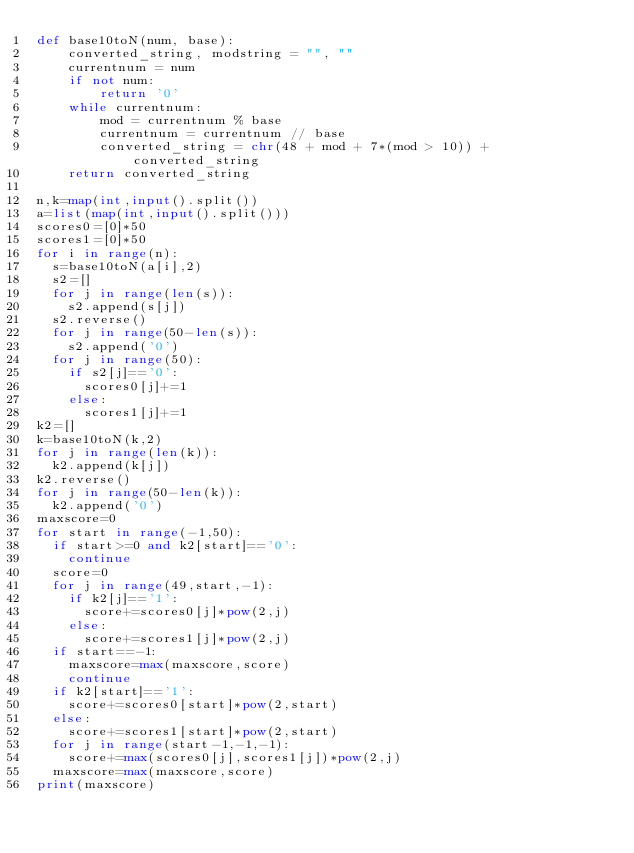<code> <loc_0><loc_0><loc_500><loc_500><_Python_>def base10toN(num, base):
    converted_string, modstring = "", ""
    currentnum = num
    if not num:
        return '0'
    while currentnum:
        mod = currentnum % base
        currentnum = currentnum // base
        converted_string = chr(48 + mod + 7*(mod > 10)) + converted_string
    return converted_string

n,k=map(int,input().split())
a=list(map(int,input().split()))
scores0=[0]*50
scores1=[0]*50
for i in range(n):
  s=base10toN(a[i],2)
  s2=[]
  for j in range(len(s)):
    s2.append(s[j])
  s2.reverse()
  for j in range(50-len(s)):
    s2.append('0')
  for j in range(50):
    if s2[j]=='0':
      scores0[j]+=1
    else:
      scores1[j]+=1
k2=[]
k=base10toN(k,2)
for j in range(len(k)):
  k2.append(k[j])
k2.reverse()
for j in range(50-len(k)):
  k2.append('0')
maxscore=0
for start in range(-1,50):
  if start>=0 and k2[start]=='0':
    continue
  score=0
  for j in range(49,start,-1):
    if k2[j]=='1':
      score+=scores0[j]*pow(2,j)
    else:
      score+=scores1[j]*pow(2,j)
  if start==-1:
    maxscore=max(maxscore,score)
    continue
  if k2[start]=='1':
    score+=scores0[start]*pow(2,start)
  else:
    score+=scores1[start]*pow(2,start)
  for j in range(start-1,-1,-1):
    score+=max(scores0[j],scores1[j])*pow(2,j)
  maxscore=max(maxscore,score)
print(maxscore)
  </code> 